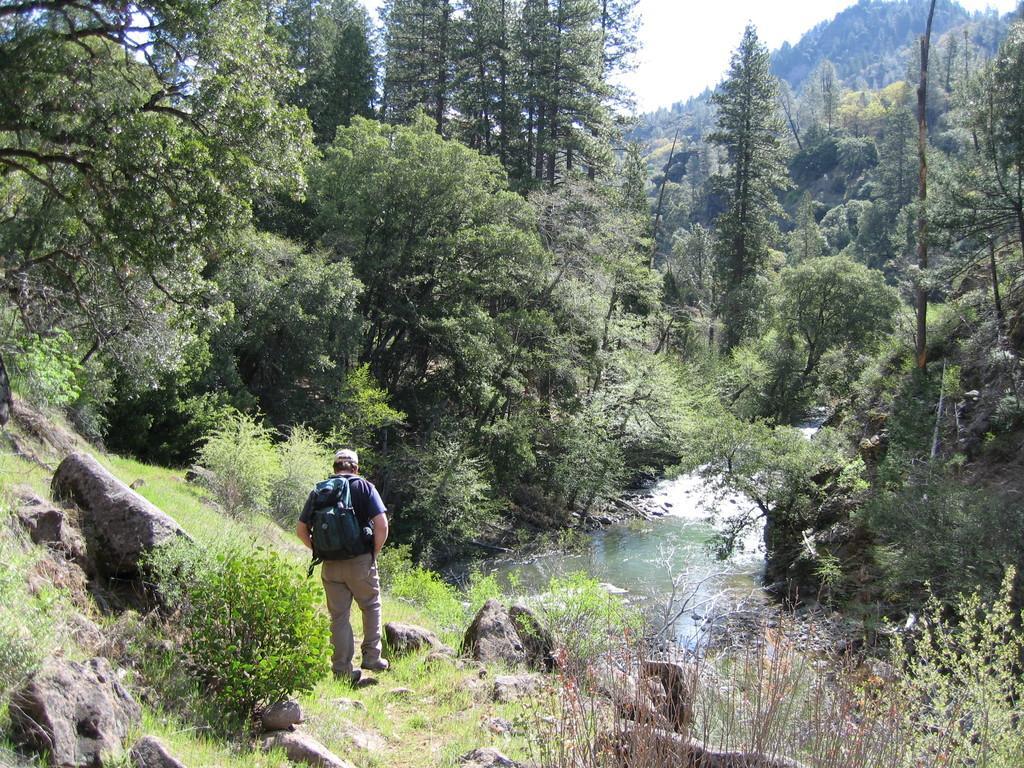Could you give a brief overview of what you see in this image? In the image we can see a person walking, wearing clothes, a cap and the person is facing back, and carrying a bag. Here we can see stones, grass and the river. Here we can see the hill and the sky. 